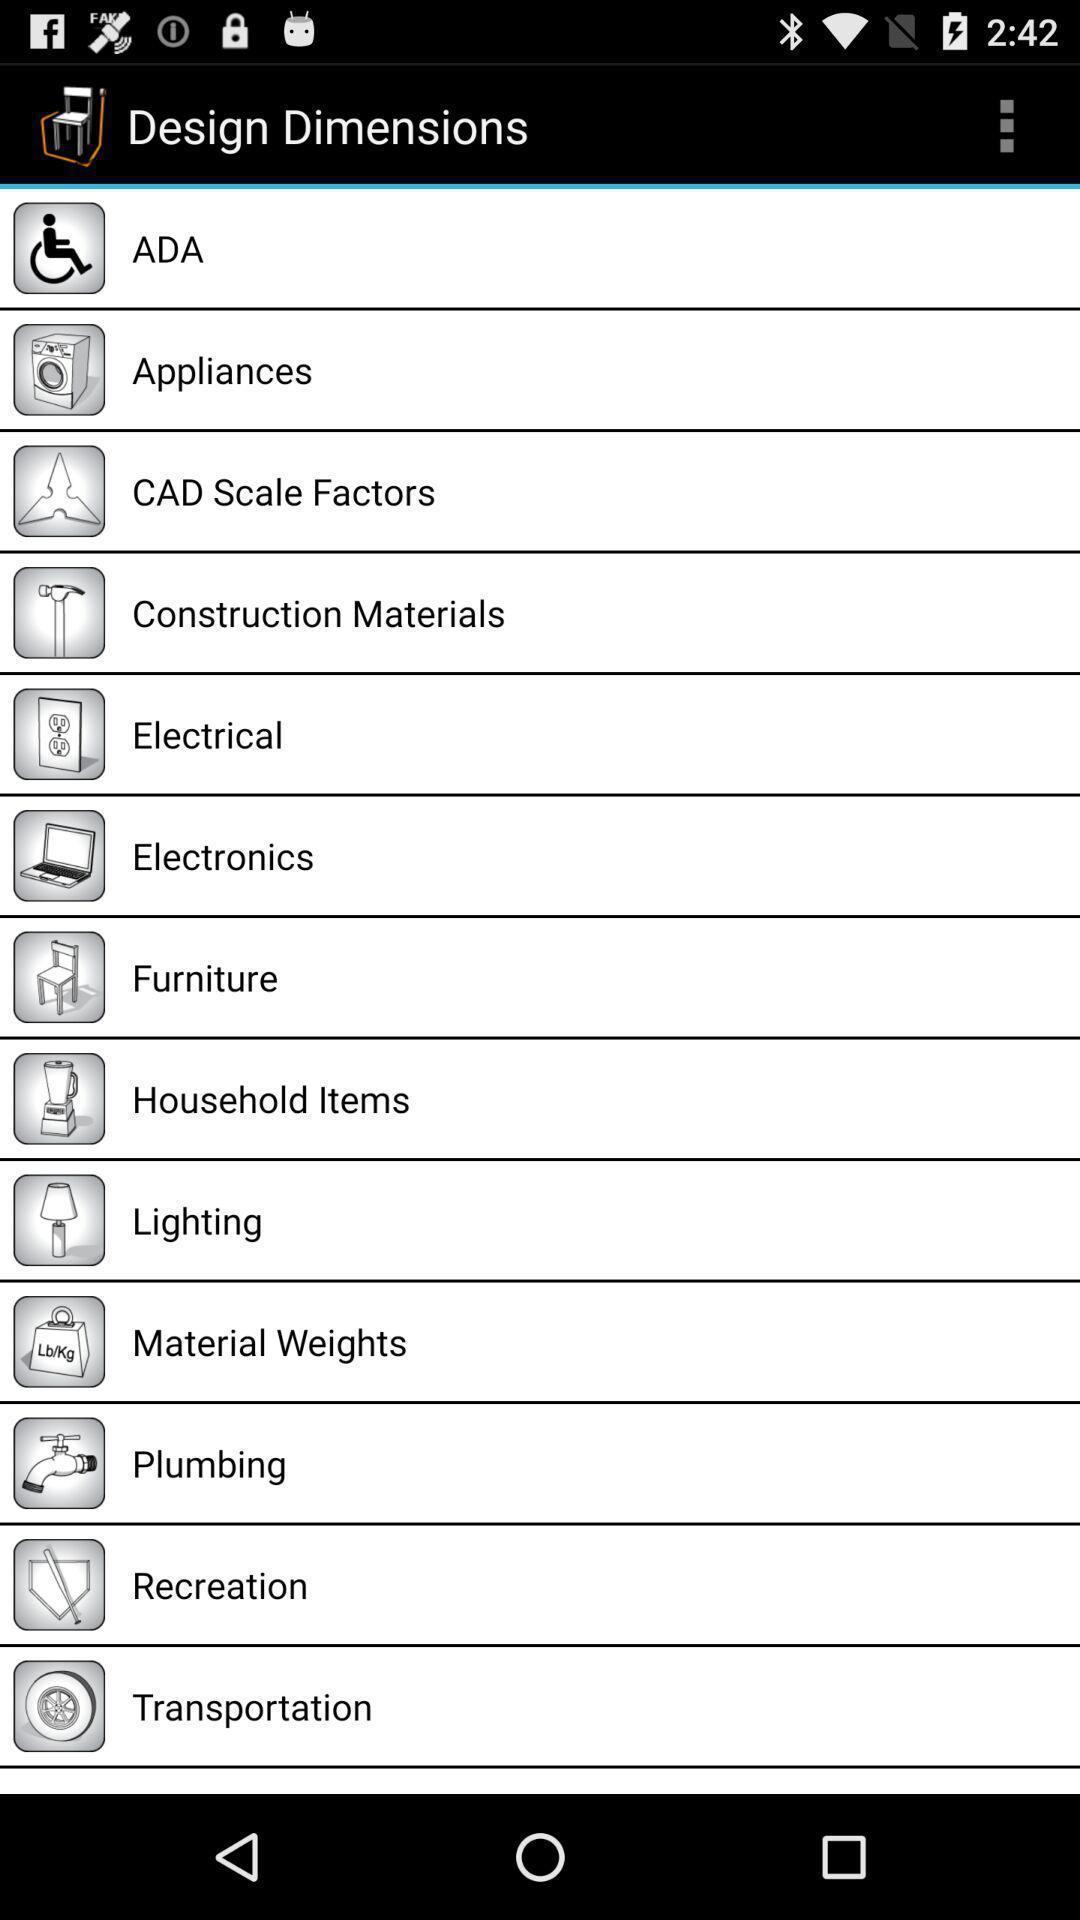Describe this image in words. Screen showing list of design dimensions. 